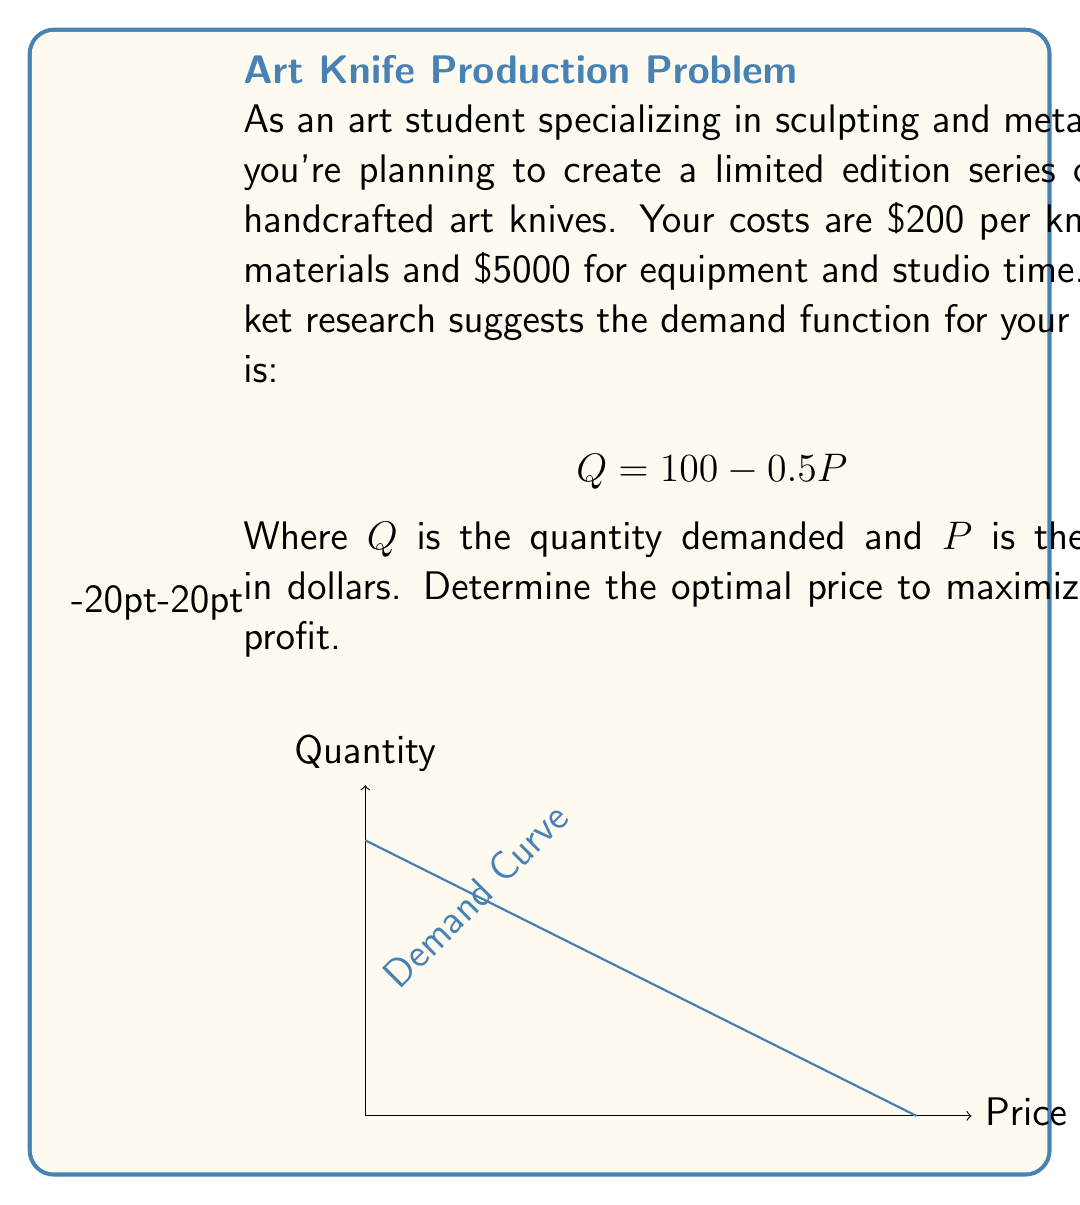Give your solution to this math problem. Let's approach this step-by-step:

1) First, let's define our profit function. Profit = Revenue - Cost
   
   $$\Pi = PQ - (200Q + 5000)$$

2) We know that $Q = 100 - 0.5P$, so let's substitute this into our profit function:
   
   $$\Pi = P(100 - 0.5P) - (200(100 - 0.5P) + 5000)$$

3) Expand the equation:
   
   $$\Pi = 100P - 0.5P^2 - 20000 + 100P - 5000$$
   $$\Pi = 200P - 0.5P^2 - 25000$$

4) To find the maximum profit, we need to find where the derivative of the profit function equals zero:
   
   $$\frac{d\Pi}{dP} = 200 - P = 0$$

5) Solve for P:
   
   $$P = 200$$

6) To confirm this is a maximum, we can check the second derivative:
   
   $$\frac{d^2\Pi}{dP^2} = -1 < 0$$

   This confirms we have a maximum.

7) At $P = 200$, the quantity sold would be:
   
   $$Q = 100 - 0.5(200) = 0$$

   This means we should price just below $200 to sell at least one knife.

8) Let's price at $199.98 to sell one knife:
   
   $$Q = 100 - 0.5(199.98) = 0.01 \approx 1$$

9) Calculate the profit at this price:
   
   $$\Pi = 199.98 * 1 - (200 * 1 + 5000) = -5000.02$$

This means that even at the optimal price, we're losing money due to the high fixed costs.
Answer: $199.98 per knife, resulting in a loss of $5000.02 